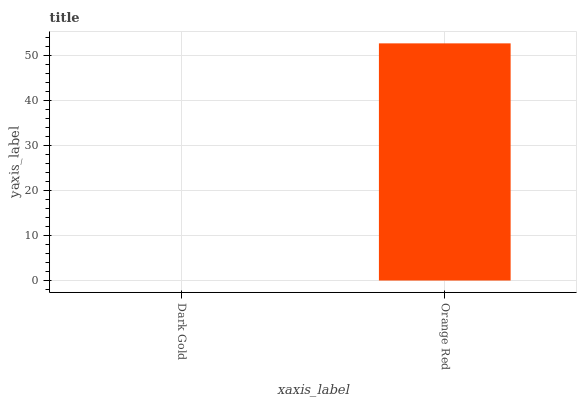Is Dark Gold the minimum?
Answer yes or no. Yes. Is Orange Red the maximum?
Answer yes or no. Yes. Is Orange Red the minimum?
Answer yes or no. No. Is Orange Red greater than Dark Gold?
Answer yes or no. Yes. Is Dark Gold less than Orange Red?
Answer yes or no. Yes. Is Dark Gold greater than Orange Red?
Answer yes or no. No. Is Orange Red less than Dark Gold?
Answer yes or no. No. Is Orange Red the high median?
Answer yes or no. Yes. Is Dark Gold the low median?
Answer yes or no. Yes. Is Dark Gold the high median?
Answer yes or no. No. Is Orange Red the low median?
Answer yes or no. No. 